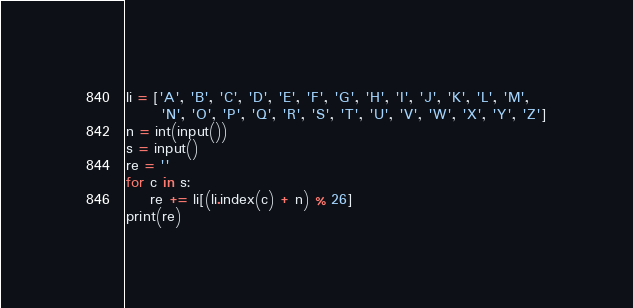<code> <loc_0><loc_0><loc_500><loc_500><_Python_>li = ['A', 'B', 'C', 'D', 'E', 'F', 'G', 'H', 'I', 'J', 'K', 'L', 'M',
      'N', 'O', 'P', 'Q', 'R', 'S', 'T', 'U', 'V', 'W', 'X', 'Y', 'Z']
n = int(input())
s = input()
re = ''
for c in s:
    re += li[(li.index(c) + n) % 26]
print(re)
</code> 